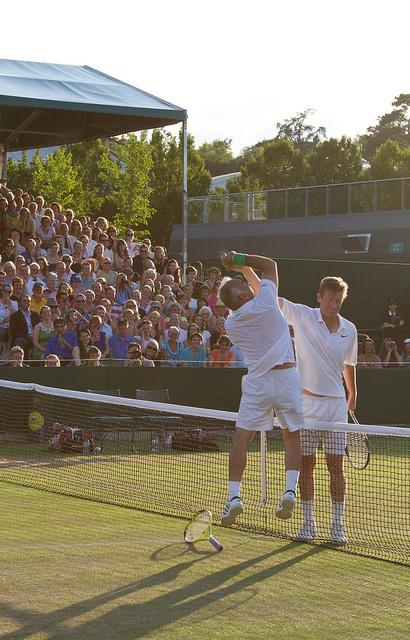What is the profession of the men in white? tennis players 